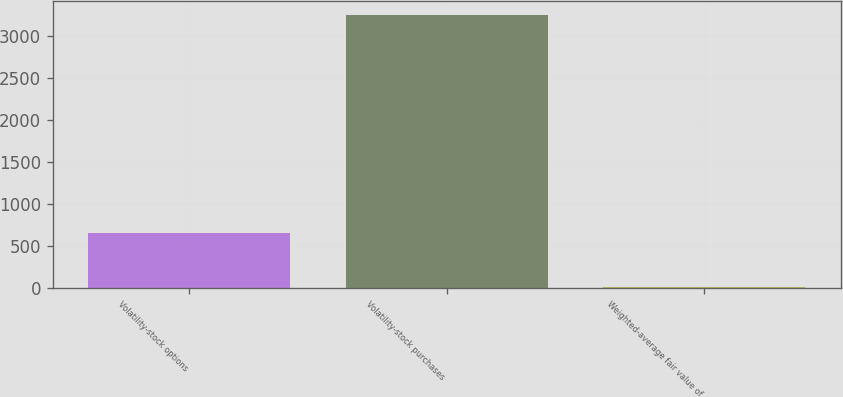Convert chart. <chart><loc_0><loc_0><loc_500><loc_500><bar_chart><fcel>Volatility-stock options<fcel>Volatility-stock purchases<fcel>Weighted-average fair value of<nl><fcel>653.24<fcel>3244<fcel>5.56<nl></chart> 